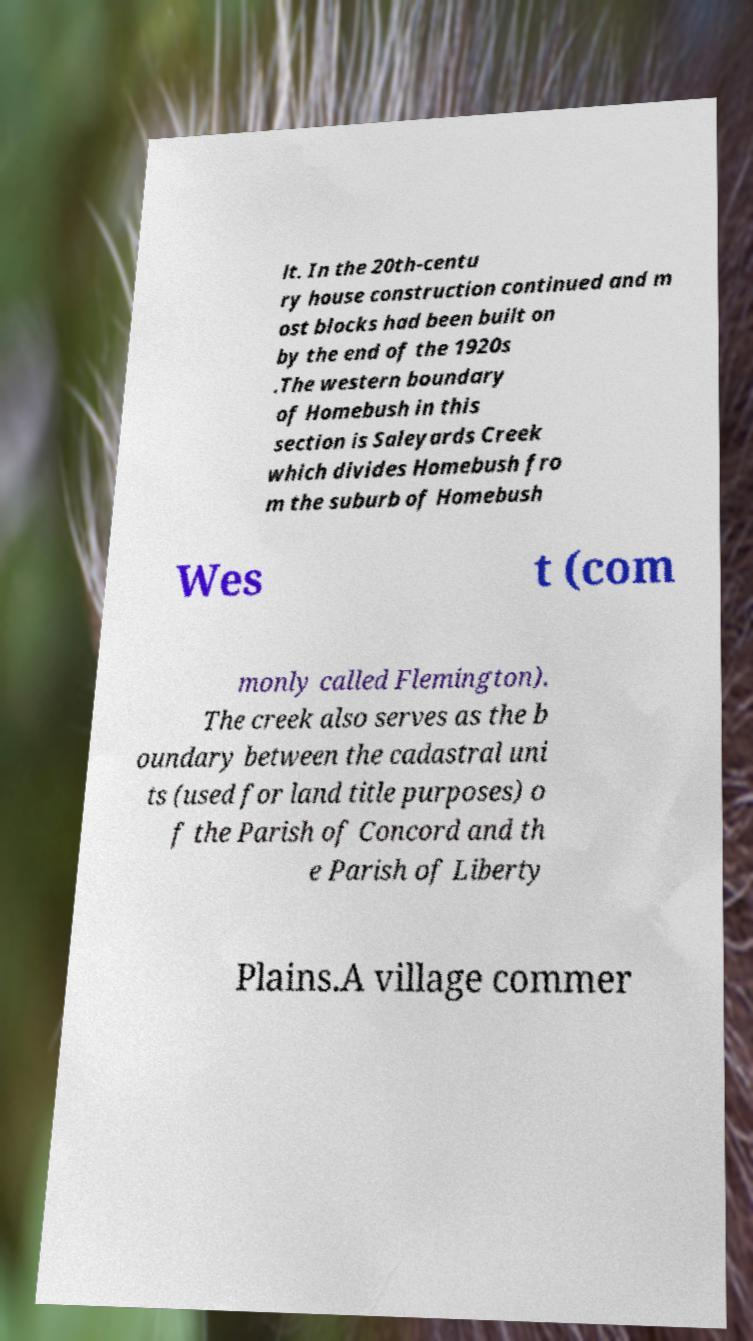Please read and relay the text visible in this image. What does it say? lt. In the 20th-centu ry house construction continued and m ost blocks had been built on by the end of the 1920s .The western boundary of Homebush in this section is Saleyards Creek which divides Homebush fro m the suburb of Homebush Wes t (com monly called Flemington). The creek also serves as the b oundary between the cadastral uni ts (used for land title purposes) o f the Parish of Concord and th e Parish of Liberty Plains.A village commer 